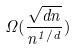Convert formula to latex. <formula><loc_0><loc_0><loc_500><loc_500>\Omega ( \frac { \sqrt { d n } } { n ^ { 1 / d } } )</formula> 